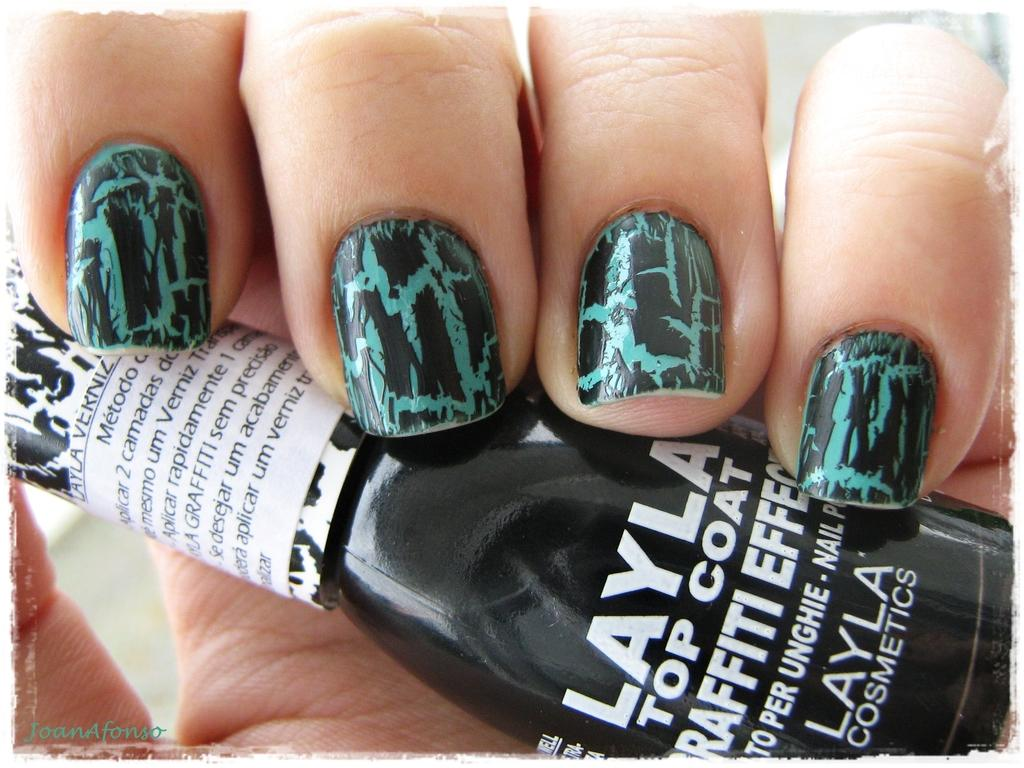What object is being held by a person in the image? There is a cosmetic bottle in the image, and it is being held by a person. What can be inferred about the person's activity in the image? The person is likely applying or using the cosmetic product from the bottle. What additional information is provided at the bottom of the image? There is some text at the bottom of the image. What is the plot of the story being told in the image? There is no story being told in the image; it simply shows a person holding a cosmetic bottle. 